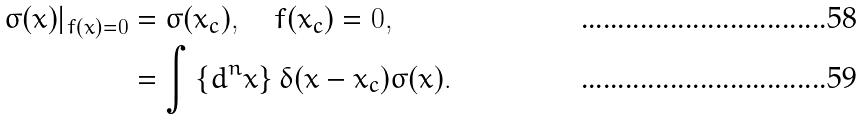<formula> <loc_0><loc_0><loc_500><loc_500>\sigma ( x ) | _ { f ( x ) = 0 } & = \sigma ( x _ { c } ) , \quad f ( x _ { c } ) = 0 , \\ & = \int \left \{ d ^ { n } x \right \} \delta ( x - x _ { c } ) \sigma ( x ) .</formula> 